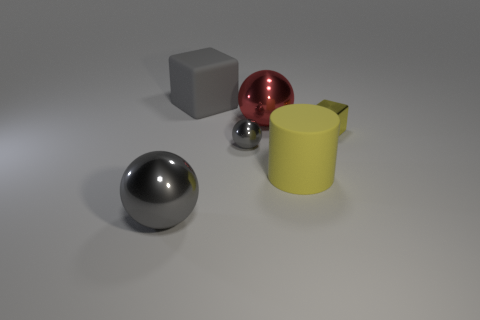Do the big gray block and the big sphere behind the cylinder have the same material?
Your answer should be very brief. No. Are there any big things that have the same color as the large cube?
Ensure brevity in your answer.  Yes. What number of other objects are the same material as the small yellow cube?
Provide a short and direct response. 3. Is the color of the big block the same as the large metal ball to the left of the big red metallic object?
Your response must be concise. Yes. Is the number of metallic spheres that are to the left of the red metallic ball greater than the number of tiny matte objects?
Offer a very short reply. Yes. What number of red objects are on the right side of the red thing behind the small metal thing that is in front of the small yellow thing?
Provide a succinct answer. 0. There is a gray metal thing that is behind the large yellow matte thing; is its shape the same as the big gray metal thing?
Provide a short and direct response. Yes. What is the gray ball that is behind the big yellow cylinder made of?
Offer a terse response. Metal. What shape is the thing that is on the left side of the tiny block and on the right side of the red metal thing?
Your answer should be compact. Cylinder. What is the big block made of?
Your answer should be compact. Rubber. 